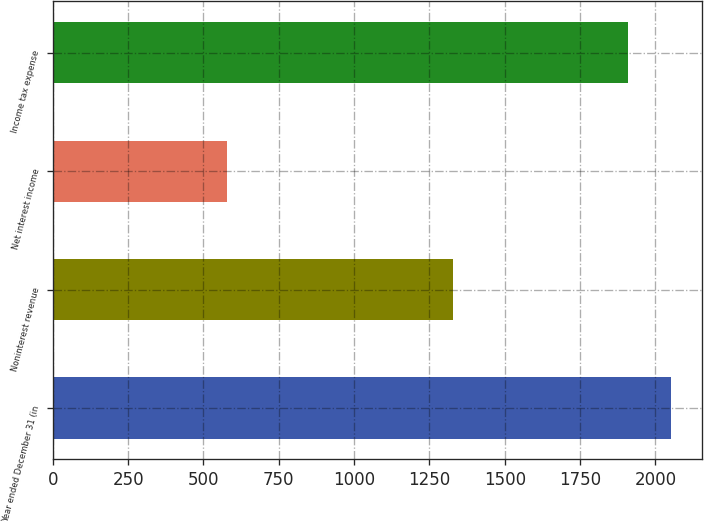Convert chart. <chart><loc_0><loc_0><loc_500><loc_500><bar_chart><fcel>Year ended December 31 (in<fcel>Noninterest revenue<fcel>Net interest income<fcel>Income tax expense<nl><fcel>2050.9<fcel>1329<fcel>579<fcel>1908<nl></chart> 